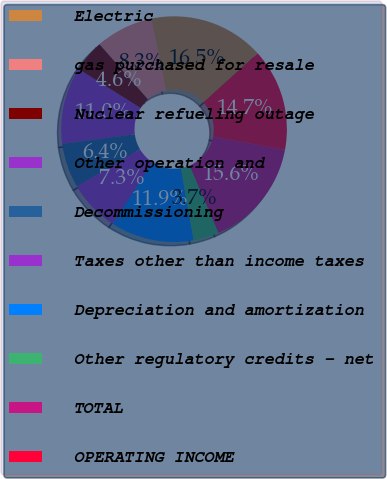<chart> <loc_0><loc_0><loc_500><loc_500><pie_chart><fcel>Electric<fcel>gas purchased for resale<fcel>Nuclear refueling outage<fcel>Other operation and<fcel>Decommissioning<fcel>Taxes other than income taxes<fcel>Depreciation and amortization<fcel>Other regulatory credits - net<fcel>TOTAL<fcel>OPERATING INCOME<nl><fcel>16.51%<fcel>8.26%<fcel>4.59%<fcel>11.01%<fcel>6.42%<fcel>7.34%<fcel>11.93%<fcel>3.67%<fcel>15.6%<fcel>14.68%<nl></chart> 